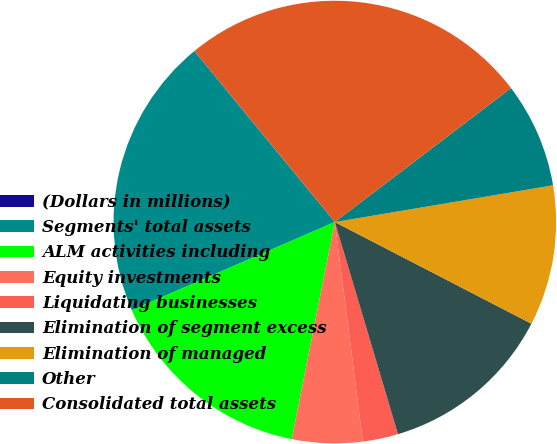Convert chart. <chart><loc_0><loc_0><loc_500><loc_500><pie_chart><fcel>(Dollars in millions)<fcel>Segments' total assets<fcel>ALM activities including<fcel>Equity investments<fcel>Liquidating businesses<fcel>Elimination of segment excess<fcel>Elimination of managed<fcel>Other<fcel>Consolidated total assets<nl><fcel>0.03%<fcel>20.56%<fcel>15.36%<fcel>5.14%<fcel>2.58%<fcel>12.8%<fcel>10.25%<fcel>7.69%<fcel>25.58%<nl></chart> 